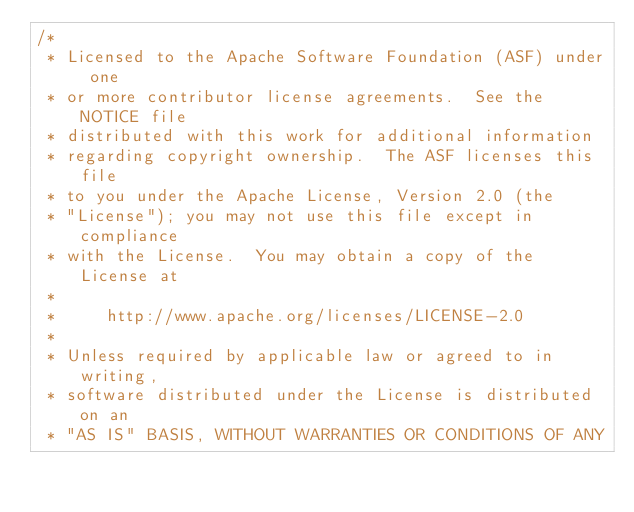Convert code to text. <code><loc_0><loc_0><loc_500><loc_500><_Java_>/*
 * Licensed to the Apache Software Foundation (ASF) under one
 * or more contributor license agreements.  See the NOTICE file
 * distributed with this work for additional information
 * regarding copyright ownership.  The ASF licenses this file
 * to you under the Apache License, Version 2.0 (the
 * "License"); you may not use this file except in compliance
 * with the License.  You may obtain a copy of the License at
 *
 *     http://www.apache.org/licenses/LICENSE-2.0
 *
 * Unless required by applicable law or agreed to in writing,
 * software distributed under the License is distributed on an
 * "AS IS" BASIS, WITHOUT WARRANTIES OR CONDITIONS OF ANY</code> 